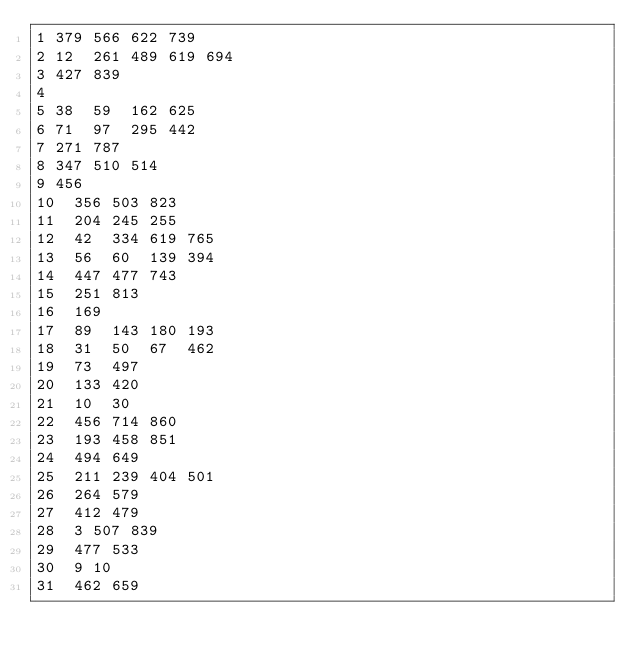Convert code to text. <code><loc_0><loc_0><loc_500><loc_500><_Perl_>1	379	566	622	739
2	12	261	489	619	694
3	427	839
4
5	38	59	162	625
6	71	97	295	442
7	271	787
8	347	510	514
9	456
10	356	503	823
11	204	245	255
12	42	334	619	765
13	56	60	139	394
14	447	477	743
15	251	813
16	169
17	89	143	180	193
18	31	50	67	462
19	73	497
20	133	420
21	10	30
22	456	714	860
23	193	458	851
24	494	649
25	211	239	404	501
26	264	579
27	412	479
28	3	507	839
29	477	533
30	9	10
31	462	659</code> 